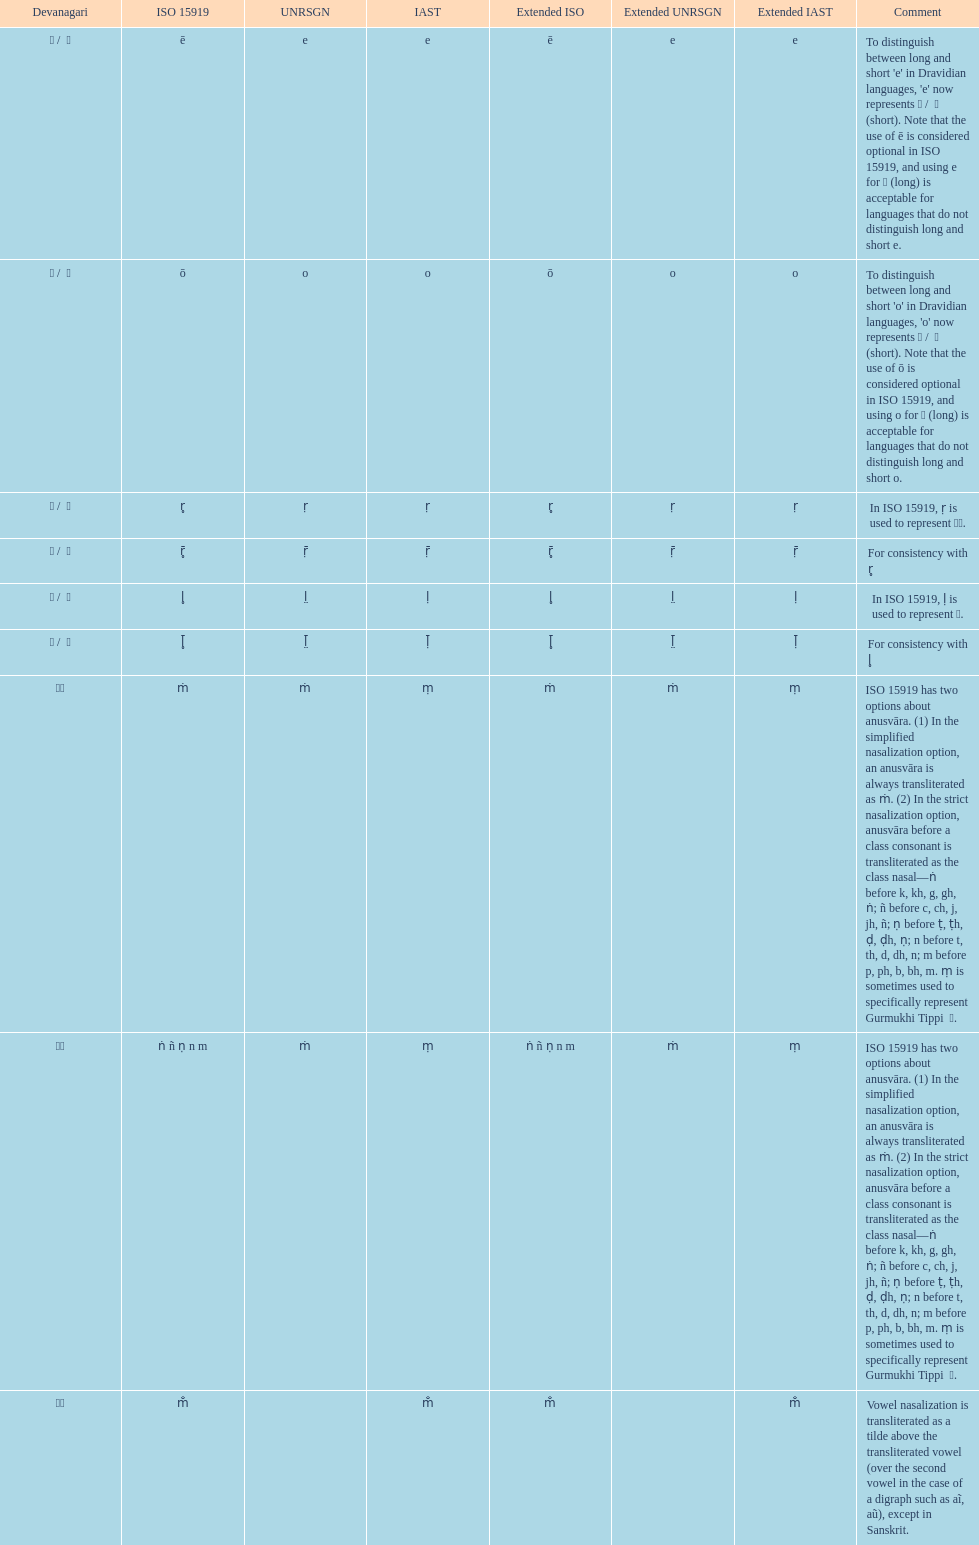Could you parse the entire table as a dict? {'header': ['Devanagari', 'ISO 15919', 'UNRSGN', 'IAST', 'Extended ISO', 'Extended UNRSGN', 'Extended IAST', 'Comment'], 'rows': [['ए / \xa0े', 'ē', 'e', 'e', 'ē', 'e', 'e', "To distinguish between long and short 'e' in Dravidian languages, 'e' now represents ऎ / \xa0ॆ (short). Note that the use of ē is considered optional in ISO 15919, and using e for ए (long) is acceptable for languages that do not distinguish long and short e."], ['ओ / \xa0ो', 'ō', 'o', 'o', 'ō', 'o', 'o', "To distinguish between long and short 'o' in Dravidian languages, 'o' now represents ऒ / \xa0ॊ (short). Note that the use of ō is considered optional in ISO 15919, and using o for ओ (long) is acceptable for languages that do not distinguish long and short o."], ['ऋ / \xa0ृ', 'r̥', 'ṛ', 'ṛ', 'r̥', 'ṛ', 'ṛ', 'In ISO 15919, ṛ is used to represent ड़.'], ['ॠ / \xa0ॄ', 'r̥̄', 'ṝ', 'ṝ', 'r̥̄', 'ṝ', 'ṝ', 'For consistency with r̥'], ['ऌ / \xa0ॢ', 'l̥', 'l̤', 'ḷ', 'l̥', 'l̤', 'ḷ', 'In ISO 15919, ḷ is used to represent ळ.'], ['ॡ / \xa0ॣ', 'l̥̄', 'l̤̄', 'ḹ', 'l̥̄', 'l̤̄', 'ḹ', 'For consistency with l̥'], ['◌ं', 'ṁ', 'ṁ', 'ṃ', 'ṁ', 'ṁ', 'ṃ', 'ISO 15919 has two options about anusvāra. (1) In the simplified nasalization option, an anusvāra is always transliterated as ṁ. (2) In the strict nasalization option, anusvāra before a class consonant is transliterated as the class nasal—ṅ before k, kh, g, gh, ṅ; ñ before c, ch, j, jh, ñ; ṇ before ṭ, ṭh, ḍ, ḍh, ṇ; n before t, th, d, dh, n; m before p, ph, b, bh, m. ṃ is sometimes used to specifically represent Gurmukhi Tippi \xa0ੰ.'], ['◌ं', 'ṅ ñ ṇ n m', 'ṁ', 'ṃ', 'ṅ ñ ṇ n m', 'ṁ', 'ṃ', 'ISO 15919 has two options about anusvāra. (1) In the simplified nasalization option, an anusvāra is always transliterated as ṁ. (2) In the strict nasalization option, anusvāra before a class consonant is transliterated as the class nasal—ṅ before k, kh, g, gh, ṅ; ñ before c, ch, j, jh, ñ; ṇ before ṭ, ṭh, ḍ, ḍh, ṇ; n before t, th, d, dh, n; m before p, ph, b, bh, m. ṃ is sometimes used to specifically represent Gurmukhi Tippi \xa0ੰ.'], ['◌ँ', 'm̐', '', 'm̐', 'm̐', '', 'm̐', 'Vowel nasalization is transliterated as a tilde above the transliterated vowel (over the second vowel in the case of a digraph such as aĩ, aũ), except in Sanskrit.']]} Which devanagari transliteration is listed on the top of the table? ए / े. 